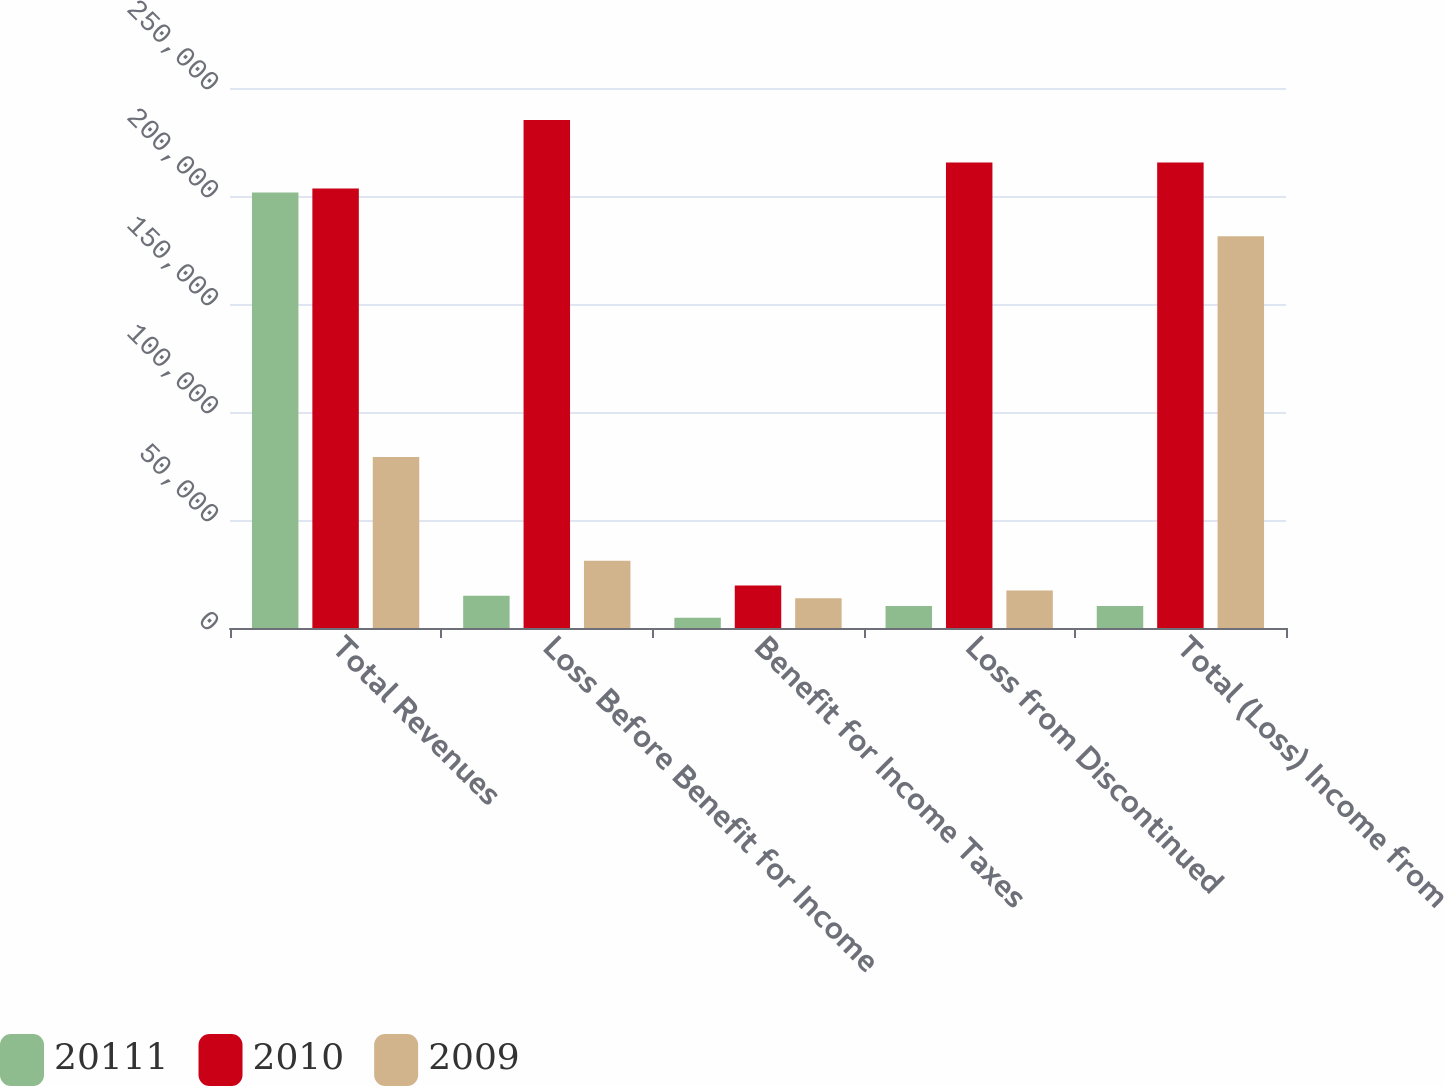Convert chart to OTSL. <chart><loc_0><loc_0><loc_500><loc_500><stacked_bar_chart><ecel><fcel>Total Revenues<fcel>Loss Before Benefit for Income<fcel>Benefit for Income Taxes<fcel>Loss from Discontinued<fcel>Total (Loss) Income from<nl><fcel>20111<fcel>201651<fcel>14959<fcel>4791<fcel>10168<fcel>10168<nl><fcel>2010<fcel>203479<fcel>235161<fcel>19682<fcel>215479<fcel>215479<nl><fcel>2009<fcel>79199<fcel>31094<fcel>13744<fcel>17350<fcel>181385<nl></chart> 